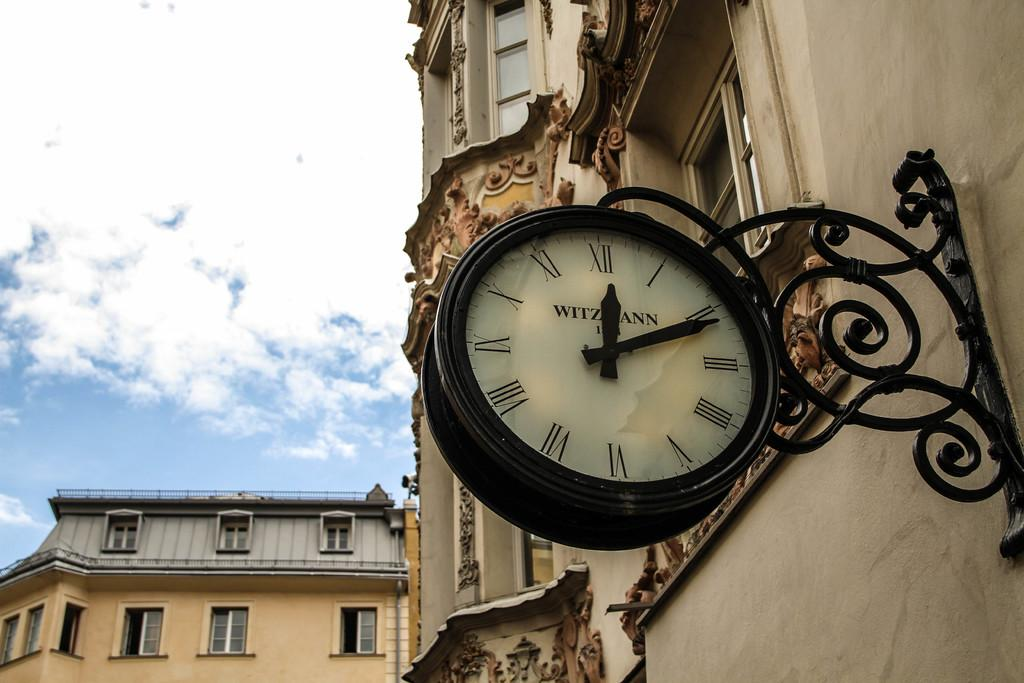<image>
Summarize the visual content of the image. An outdoor clock attached to a building shows that is is 12:11. 